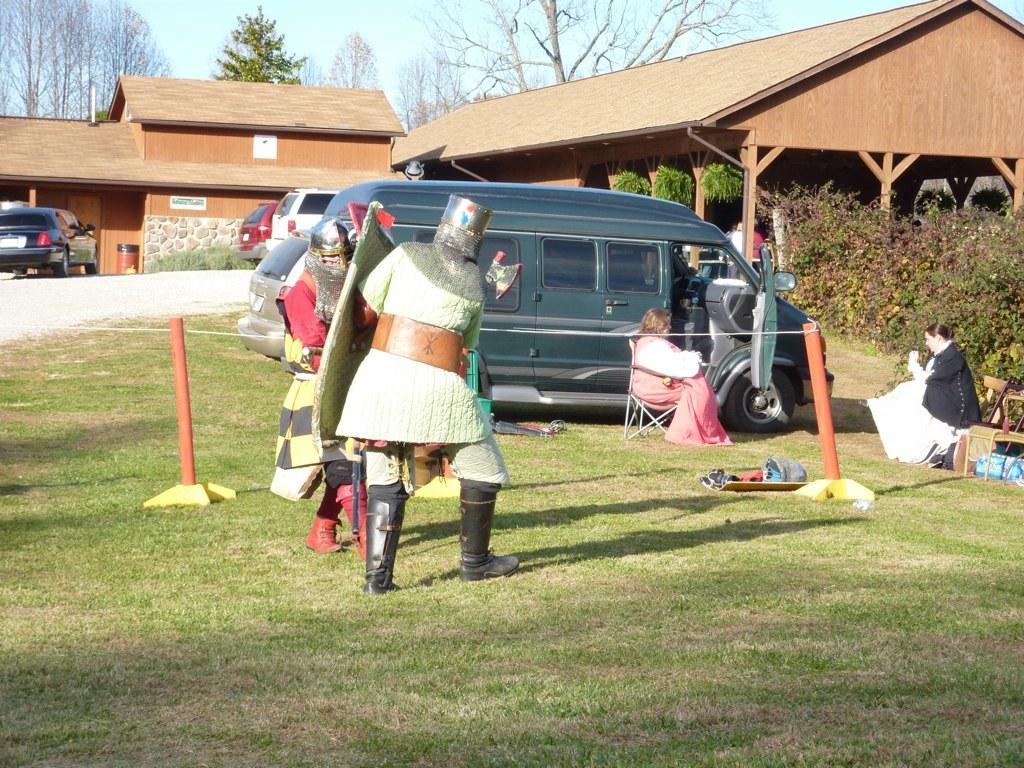Describe this image in one or two sentences. In this image there is the sky, there are trees, there is house, there is a vehicle truncated towards the left of the image, there are plants, there are vehicles, there is grass, there are objects on the grass, there is a chair truncated towards the right of the image, there are two persons sitting on the chair, there are two person standing and holding an objects, there are stands, there is a rope truncated towards the left of the image, there are plants truncated towards the right of the image. 